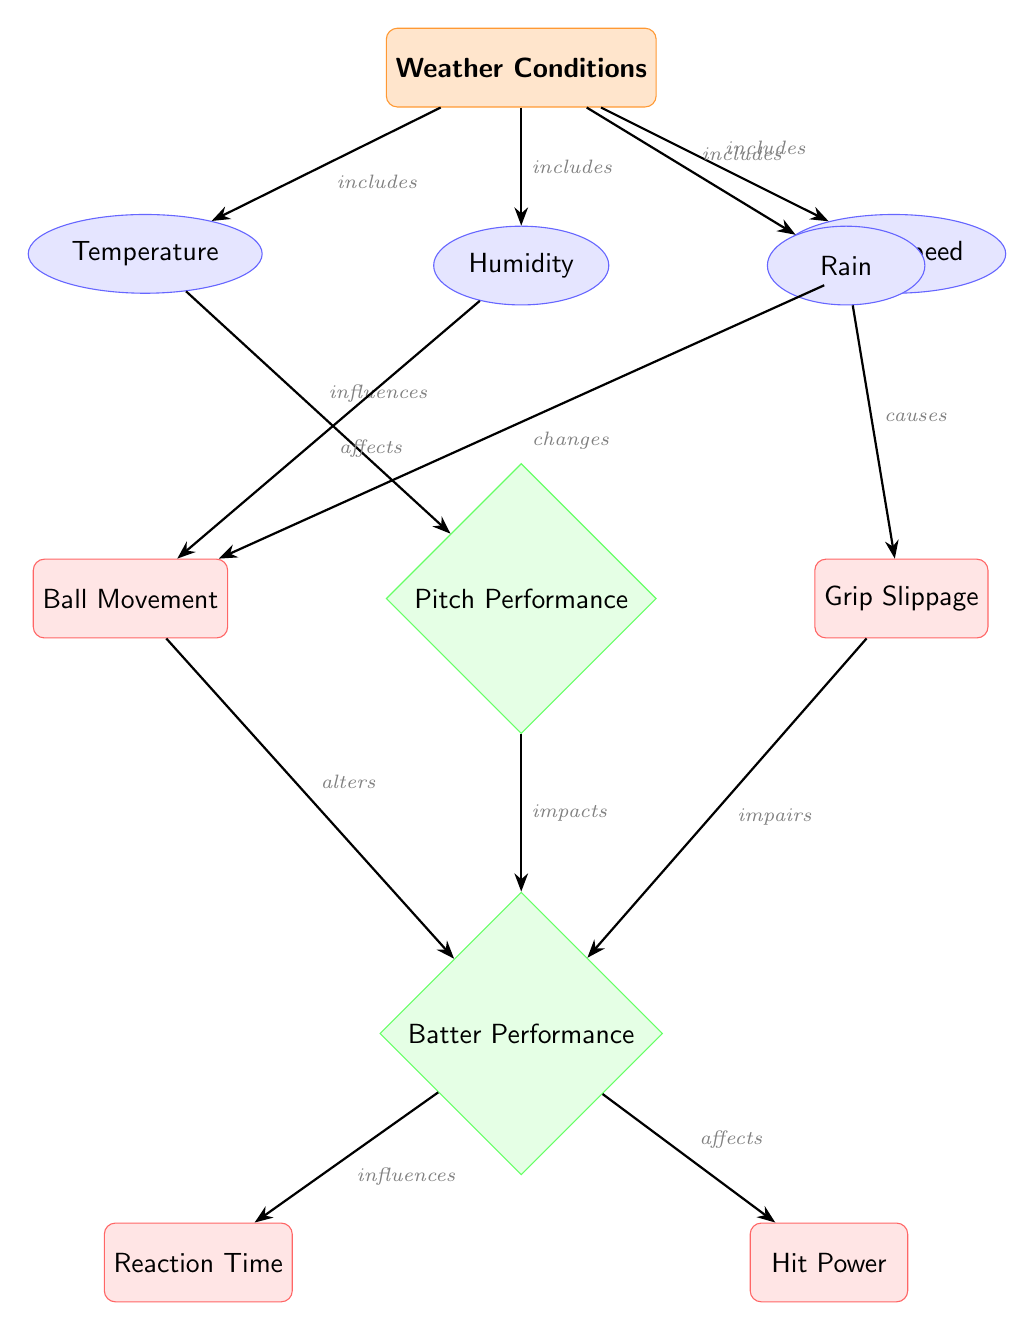What are the conditions included under Weather Conditions? The Weather Conditions node includes Temperature, Humidity, Wind Speed, and Rain as its connected nodes that describe varying aspects of the weather affecting baseball conditions.
Answer: Temperature, Humidity, Wind Speed, Rain How many nodes are there in the diagram? The diagram contains a total of 8 nodes: 4 for weather conditions, 2 for pitch performance, and 2 for batter performance, making a total of 8.
Answer: 8 What does Wind Speed influence in the diagram? The Wind Speed node directly influences the Ball Movement, as indicated by the edge labeled "changes" that connects Wind Speed to Ball Movement.
Answer: Movement How does Temperature affect Pitch Performance? The diagram indicates that Temperature influences Pitch Performance, as shown by the direct edge labeled "influences" connecting Temperature to Pitch Performance, meaning changes in temperature can directly affect how well a pitcher performs.
Answer: Influences Which outcome does Grip Slippage impair? The diagram shows that Grip Slippage impacts Batter Performance, specifically impairing the batter's ability to perform well, as shown by the edge labeled "impairs" that connects Grip Slippage to Batter Performance.
Answer: Batter Performance What is the relationship between Ball Movement and Reaction Time? The Ball Movement node alters the Batter Performance, which includes Reaction Time as one of its outcomes. This indicates that changes in ball movement can directly affect how quickly a batter reacts to the pitch.
Answer: Alters How many edges are connected to the Weather Conditions node? The Weather Conditions node has four edges connected to it, each leading to one of the weather-related conditions: Temperature, Humidity, Wind Speed, and Rain, indicating that each condition is an aspect of the weather affecting pitchers and batters.
Answer: 4 What directly causes Grip Slippage according to the diagram? The diagram states that Rain causes Grip Slippage, as indicated by the edge connecting Rain to Grip Slippage, showing that rain has a direct impact on the grip a pitcher has on the ball.
Answer: Rain What are the two outcomes under Batter Performance? Under the Batter Performance node, the two outcomes listed are Reaction Time and Hit Power, which represent the different aspects of a batter's performance impacted by various factors in the game.
Answer: Reaction Time, Hit Power 